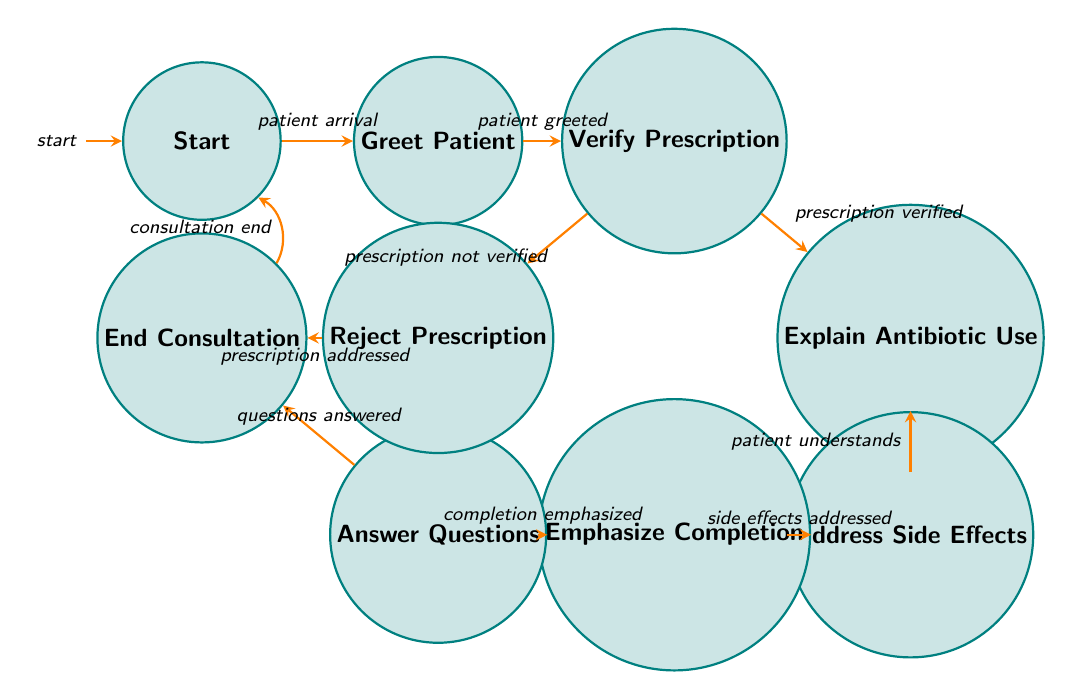What is the initial state of the diagram? The diagram starts at the "Start" state, which is the first node in the finite state machine.
Answer: Start How many states are present in this diagram? There are a total of 8 states in the diagram including the start and end states.
Answer: 8 What event leads to the "Verify Prescription" state? The event that transitions to the "Verify Prescription" state is the "patient greeted" event, which follows after the patient is greeted.
Answer: patient greeted What happens when the prescription is not verified? If the prescription is not verified, the consultation moves to the "Reject Prescription" state, as indicated by a transition for that event from the "Verify Prescription" state.
Answer: Reject Prescription What is the final state after "Answer Questions"? After the "Answer Questions" state is completed and questions are answered, the consultation moves to the "End Consultation" state.
Answer: End Consultation Which state comes after "Address Side Effects"? The "Emphasize Completion" state follows after the "Address Side Effects" state, as indicated by the transition for the event "side effects addressed."
Answer: Emphasize Completion What event returns the process to the starting point? The "consultation end" event takes the process back to the "Start" state after finishing the consultation process.
Answer: consultation end How many edges connect the "Explain Antibiotic Use" state to other states? There is only one edge leaving the "Explain Antibiotic Use" state that connects to the "Address Side Effects" state, indicating a singular transition.
Answer: 1 Which state has a direct transition to the "End Consultation"? Both the "Answer Questions" and "Reject Prescription" states have direct transitions to the "End Consultation" state, leading to the conclusion of the consultation process.
Answer: End Consultation 